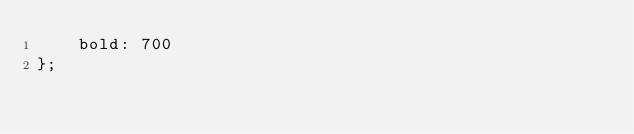Convert code to text. <code><loc_0><loc_0><loc_500><loc_500><_JavaScript_>    bold: 700
};
</code> 